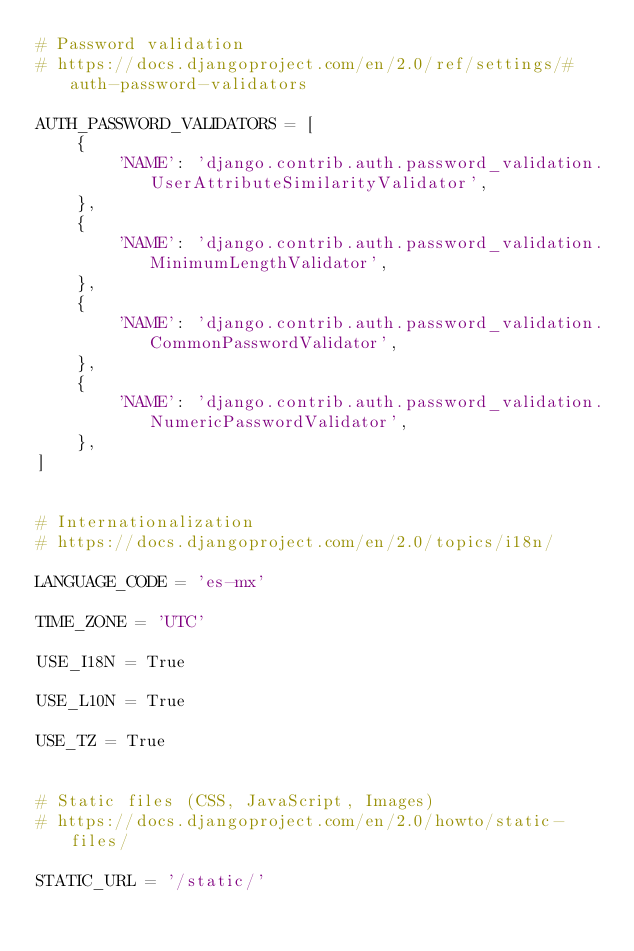<code> <loc_0><loc_0><loc_500><loc_500><_Python_># Password validation
# https://docs.djangoproject.com/en/2.0/ref/settings/#auth-password-validators

AUTH_PASSWORD_VALIDATORS = [
    {
        'NAME': 'django.contrib.auth.password_validation.UserAttributeSimilarityValidator',
    },
    {
        'NAME': 'django.contrib.auth.password_validation.MinimumLengthValidator',
    },
    {
        'NAME': 'django.contrib.auth.password_validation.CommonPasswordValidator',
    },
    {
        'NAME': 'django.contrib.auth.password_validation.NumericPasswordValidator',
    },
]


# Internationalization
# https://docs.djangoproject.com/en/2.0/topics/i18n/

LANGUAGE_CODE = 'es-mx'

TIME_ZONE = 'UTC'

USE_I18N = True

USE_L10N = True

USE_TZ = True


# Static files (CSS, JavaScript, Images)
# https://docs.djangoproject.com/en/2.0/howto/static-files/

STATIC_URL = '/static/'
</code> 